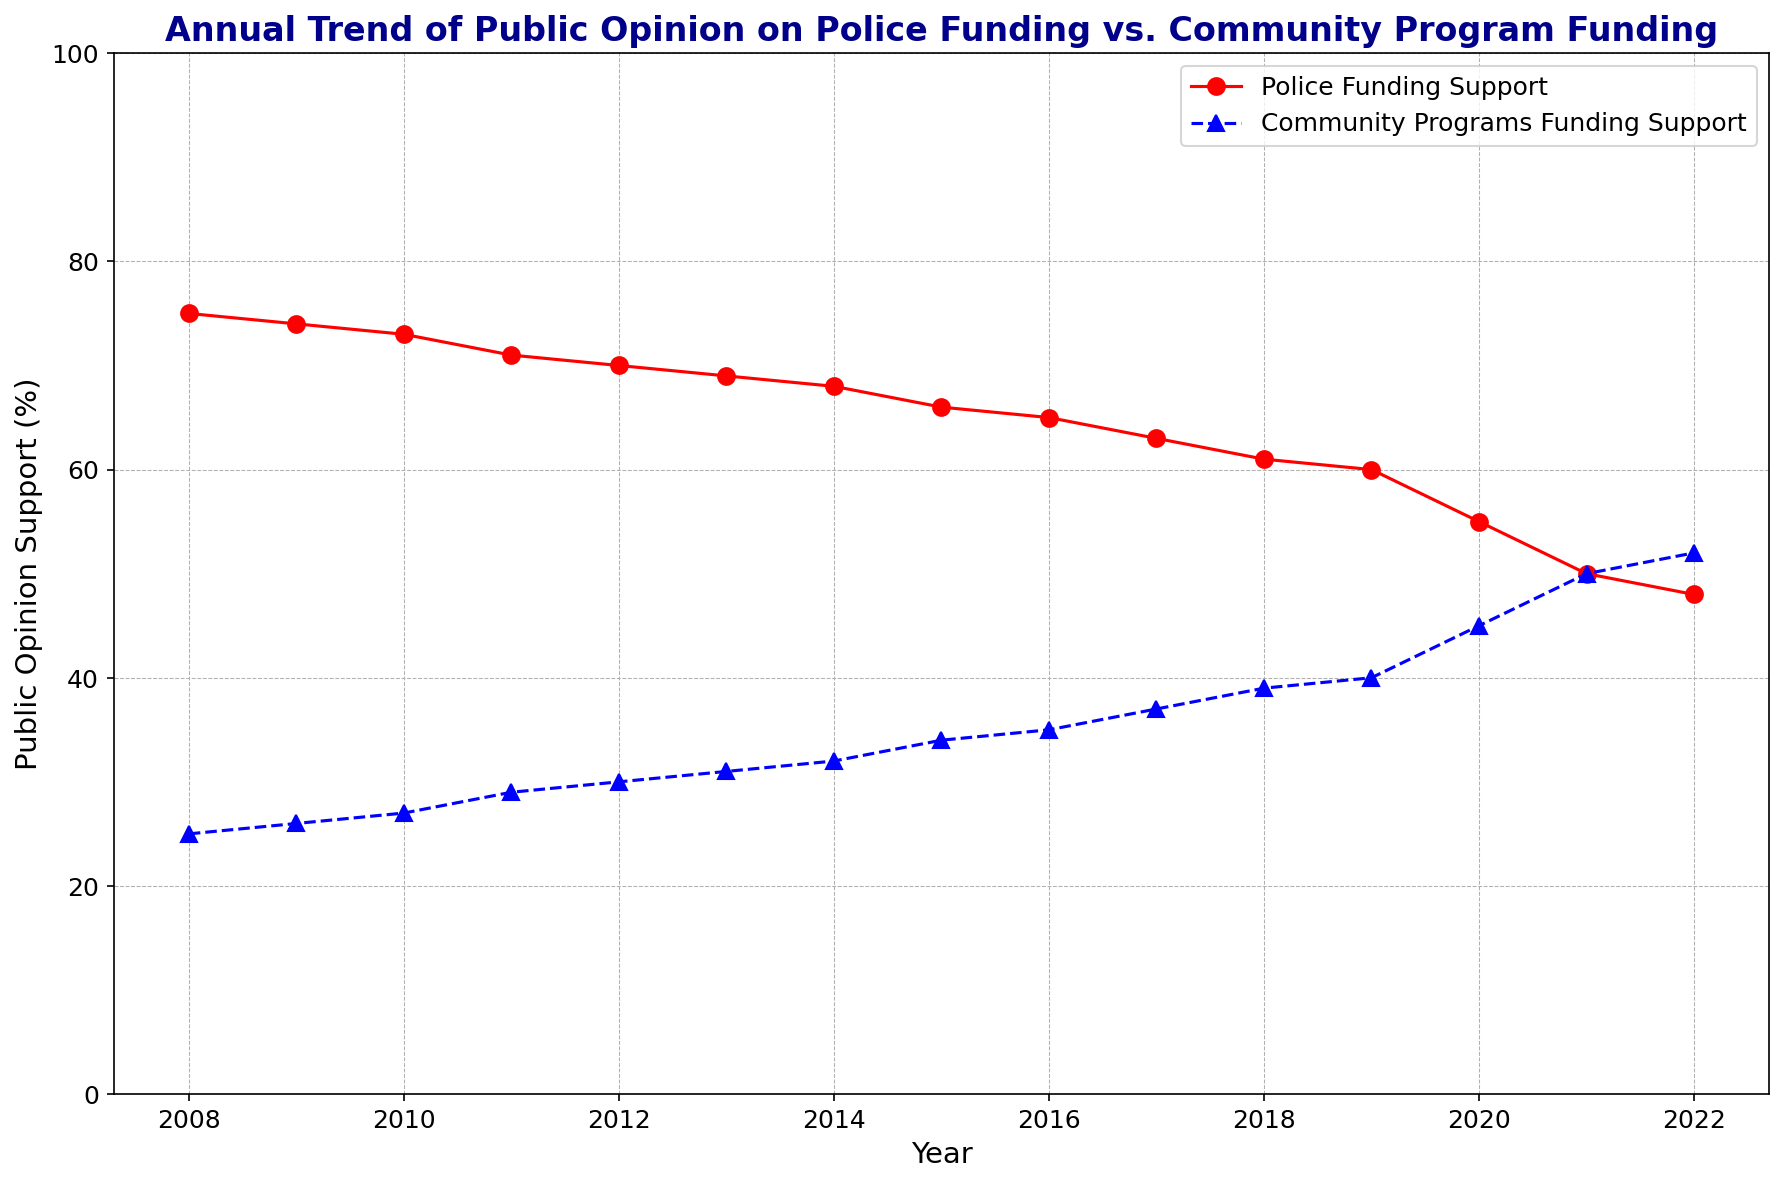What is the trend in public opinion support for police funding from 2008 to 2022? The support for police funding shows a generally downward trend from 75% in 2008 to 48% in 2022. Each year, there's a slight decrease in support.
Answer: Downward trend How does the public opinion support for community programs funding in 2022 compare to 2008? In 2008, the support for community programs funding was 25%, while in 2022 it increased to 52%.
Answer: Higher in 2022 What year did public opinion on community programs funding surpass police funding support? The two lines intersect where public opinion support for community programs funding surpasses police funding support in 2021.
Answer: 2021 By how many percentage points did police funding support decrease from 2010 to 2020? In 2010, police funding support was at 73%. By 2020, it decreased to 55%. The difference is 73 - 55 = 18 percentage points.
Answer: 18 percentage points What is the average support for community programs funding from 2017 to 2022? The values are 37, 39, 40, 45, 50, and 52 respectively. The sum is 37 + 39 + 40 + 45 + 50 + 52 = 263. The average is 263/6 ≈ 43.83.
Answer: 43.83% Which type of funding had more consistent support over the years, police or community programs? Police funding shows a consistent downward trend while community programs funding consistently rises. However, community programs show a more gradual increase compared to a relatively steeper decline for police. Both have consistency, but police funding shows a steadier decline.
Answer: Police funding (steady decline) In what year did the gap between police funding and community programs funding support narrow down to the smallest before intersecting? By examining the graph, it's clear that just before intersecting in 2021, the gap was smallest – i.e., in 2020, with a difference of 55% (police) - 45% (community programs) = 10%.
Answer: 2020 What is the cumulative support for both police and community programs funding in 2015? The support for police funding in 2015 is 66%, and for community programs, it is 34%. The cumulative support is 66 + 34 = 100%.
Answer: 100% By how many percentage points did community programs funding support increase from 2013 to 2022? In 2013, the support for community programs funding was 31%. By 2022, it increased to 52%, resulting in an increase of 52 - 31 = 21 percentage points.
Answer: 21 percentage points 